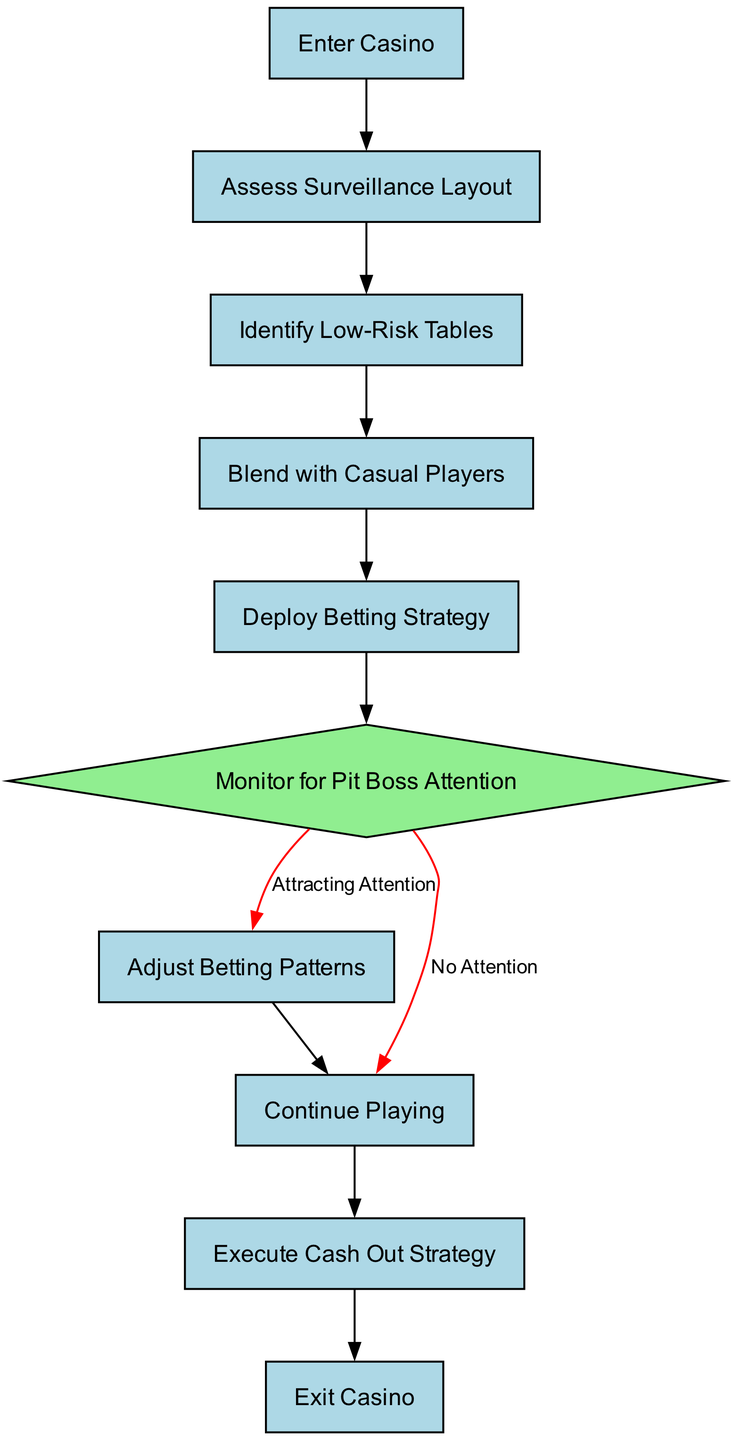What is the first activity in the process? The first activity listed in the diagram is 'Enter Casino'. Since the diagram starts with this node, it indicates the starting point of the process.
Answer: Enter Casino How many nodes are present in the diagram? The diagram contains 10 nodes total, including both activities and decisions. By counting each unique activity and decision, we arrive at this total.
Answer: 10 What activity follows 'Blend with Casual Players'? The activity that immediately follows 'Blend with Casual Players' is 'Deploy Betting Strategy', which is the next step in the flow from that node.
Answer: Deploy Betting Strategy What happens if there is 'No Attention' from the Pit Boss? If there is 'No Attention', the process continues to the 'Continue Playing' activity, indicating that there is no need to change actions at that point.
Answer: Continue Playing What is the next step after 'Adjust Betting Patterns'? After 'Adjust Betting Patterns', the next step is 'Continue Playing', showing that the process circles back to continued gameplay following adjustments.
Answer: Continue Playing How many decision points are in the diagram? There is 1 decision point present in the diagram, located at 'Monitor for Pit Boss Attention', which splits into two distinct paths based on whether attention is attracted or not.
Answer: 1 What is the final activity in the process? The final activity in the process is 'Exit Casino', which indicates the conclusion of the flow once all previous steps have been completed correctly.
Answer: Exit Casino What decision leads to 'Adjust Betting Patterns'? The decision point that leads to 'Adjust Betting Patterns' is if the choice 'Attracting Attention' is selected during 'Monitor for Pit Boss Attention', specifically indicating a need for adjustment.
Answer: Attracting Attention What indicates the likelihood of continuing play in the diagram? The likelihood of continuing play is indicated by the 'Continue Playing' activity, which is reached after both 'Deploy Betting Strategy' when there is no attention or after 'Adjust Betting Patterns'.
Answer: Continue Playing 